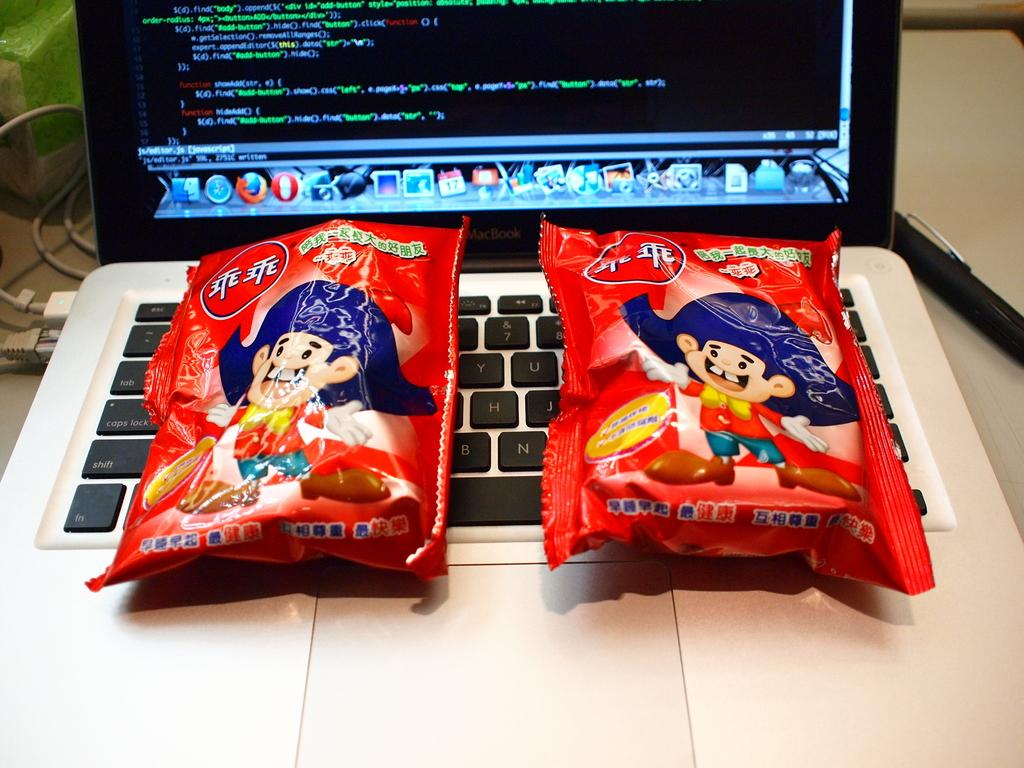What is the main object in the center of the image? There is a laptop in the center of the image. What is placed on the laptop? There are two packets visible on the laptop. What else can be seen on the left side of the image? Wires are present on the left side of the image. What type of growth can be observed on the laptop in the image? There is no growth visible on the laptop in the image. At what angle is the laptop positioned in the image? The angle at which the laptop is positioned cannot be determined from the image. 